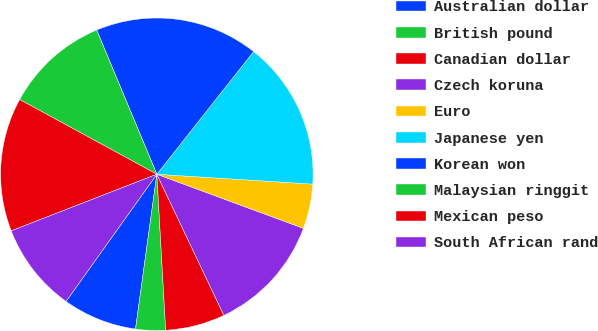<chart> <loc_0><loc_0><loc_500><loc_500><pie_chart><fcel>Australian dollar<fcel>British pound<fcel>Canadian dollar<fcel>Czech koruna<fcel>Euro<fcel>Japanese yen<fcel>Korean won<fcel>Malaysian ringgit<fcel>Mexican peso<fcel>South African rand<nl><fcel>7.69%<fcel>3.08%<fcel>6.16%<fcel>12.31%<fcel>4.62%<fcel>15.38%<fcel>16.92%<fcel>10.77%<fcel>13.84%<fcel>9.23%<nl></chart> 